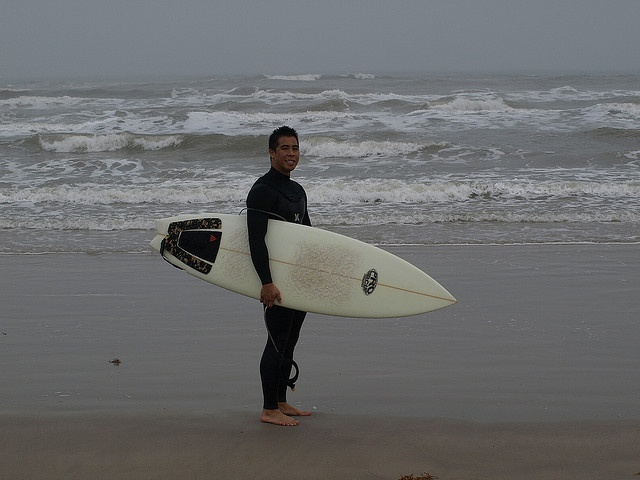Describe the objects in this image and their specific colors. I can see surfboard in gray, darkgray, and black tones and people in gray, black, and maroon tones in this image. 